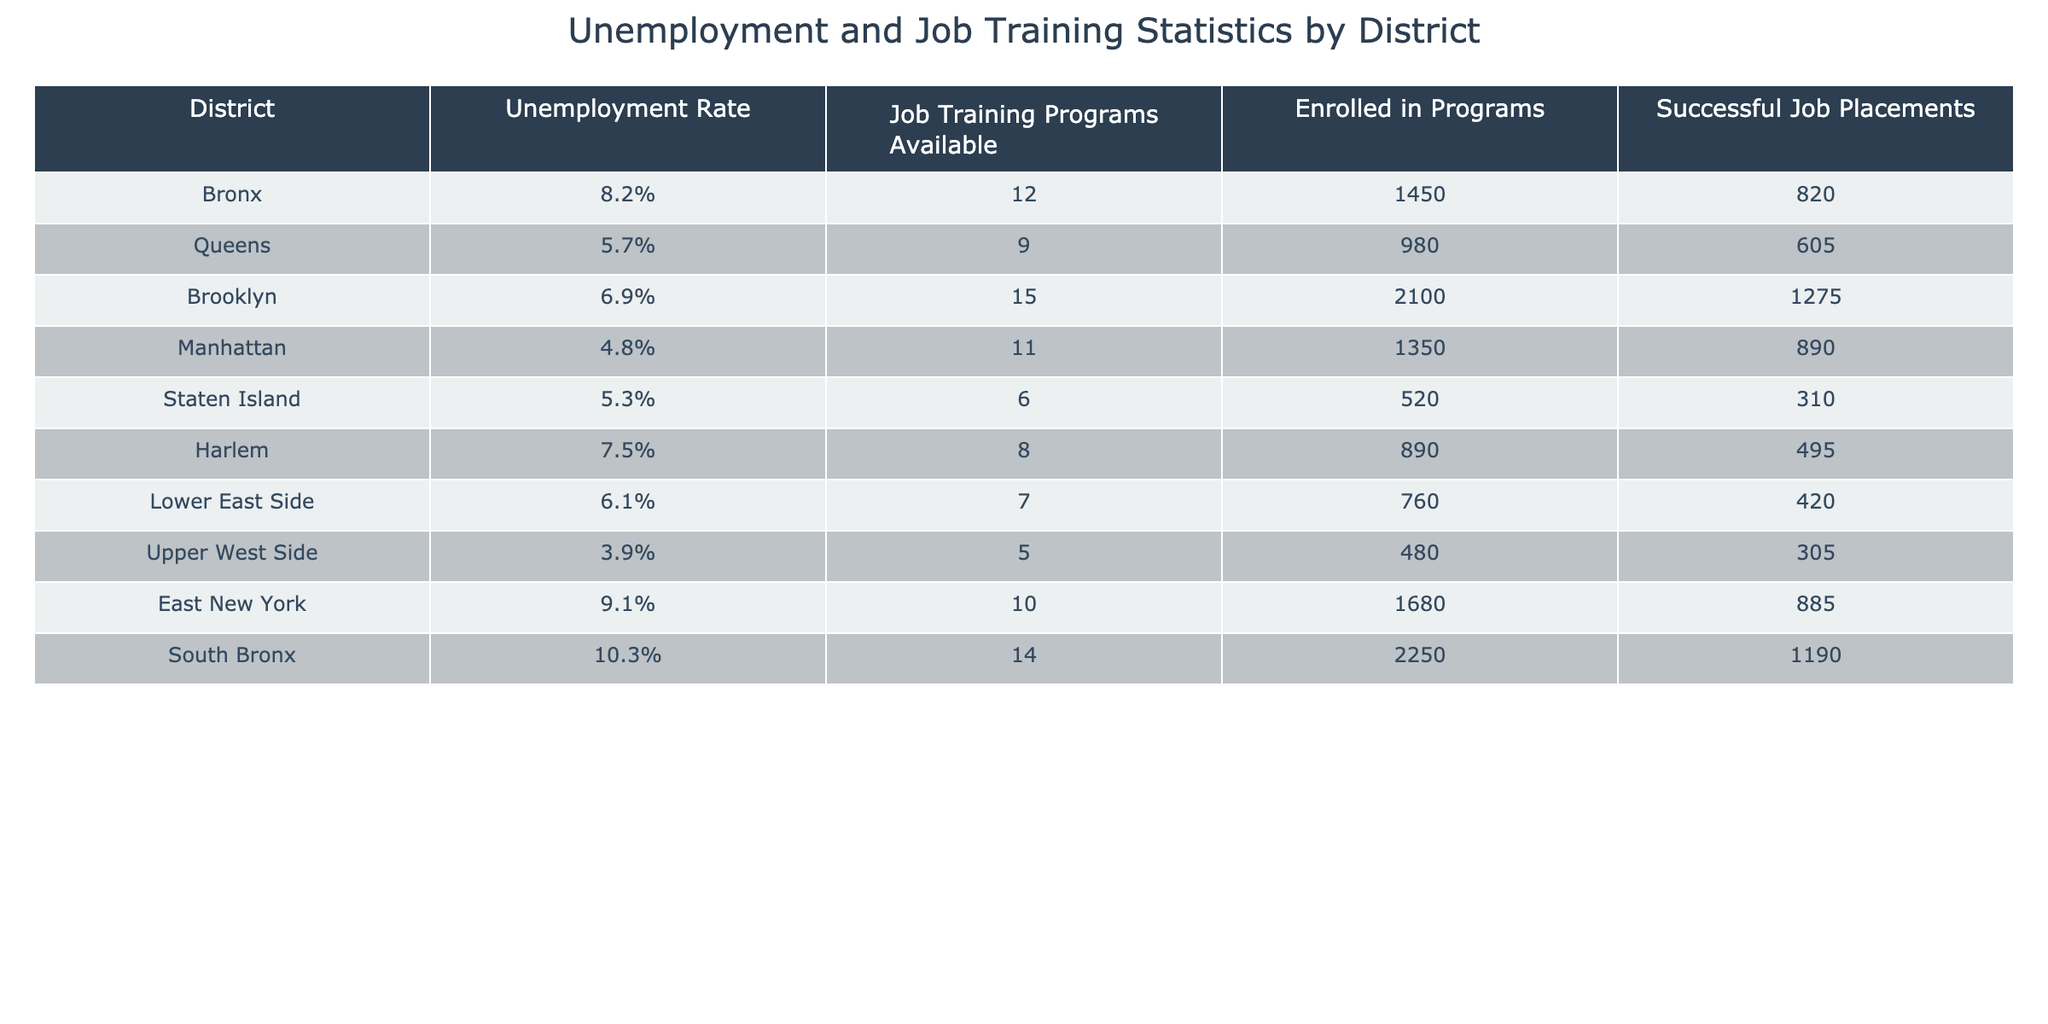What is the unemployment rate in the Bronx? The table shows that the unemployment rate for the Bronx is listed as 8.2%.
Answer: 8.2% How many job training programs are available in Brooklyn? According to the table, Brooklyn has 15 job training programs available.
Answer: 15 Which district has the highest unemployment rate? By comparing the unemployment rates in the table, South Bronx has the highest rate at 10.3%.
Answer: South Bronx How many successful job placements were there in Manhattan? The data in the table indicates that there were 890 successful job placements in Manhattan.
Answer: 890 What is the total number of enrolled participants in job training programs across all districts? Adding the enrolled participants from all districts gives (1450 + 980 + 2100 + 1350 + 520 + 890 + 760 + 480 + 1680 + 2250) = 10660 participants.
Answer: 10660 Which district had the fewest job training programs available? The table shows that Staten Island had the fewest job training programs available at 6.
Answer: Staten Island Is the unemployment rate lower in the Upper West Side compared to the Lower East Side? The unemployment rate in the Upper West Side is 3.9%, while in the Lower East Side it is 6.1%, confirming that Upper West Side has a lower rate.
Answer: Yes What is the average number of successful job placements across all districts? To find the average, sum all successful job placements (820 + 605 + 1275 + 890 + 310 + 495 + 420 + 305 + 885 + 1190) = 5050, and divide by the number of districts, 10. The average is 5050 / 10 = 505.
Answer: 505 Which district has more enrolled participants in job training programs: Harlem or Staten Island? Harlem has 890 enrolled participants while Staten Island has 520, indicating Harlem has more.
Answer: Harlem If we exclude the Bronx and South Bronx, which district has the highest unemployment rate? Excluding Bronx (8.2%) and South Bronx (10.3%), we compare the remaining districts: Queens (5.7%), Brooklyn (6.9%), Manhattan (4.8%), Staten Island (5.3%), Harlem (7.5%), Lower East Side (6.1%), Upper West Side (3.9%), and East New York (9.1%). The highest among these is East New York at 9.1%.
Answer: East New York 